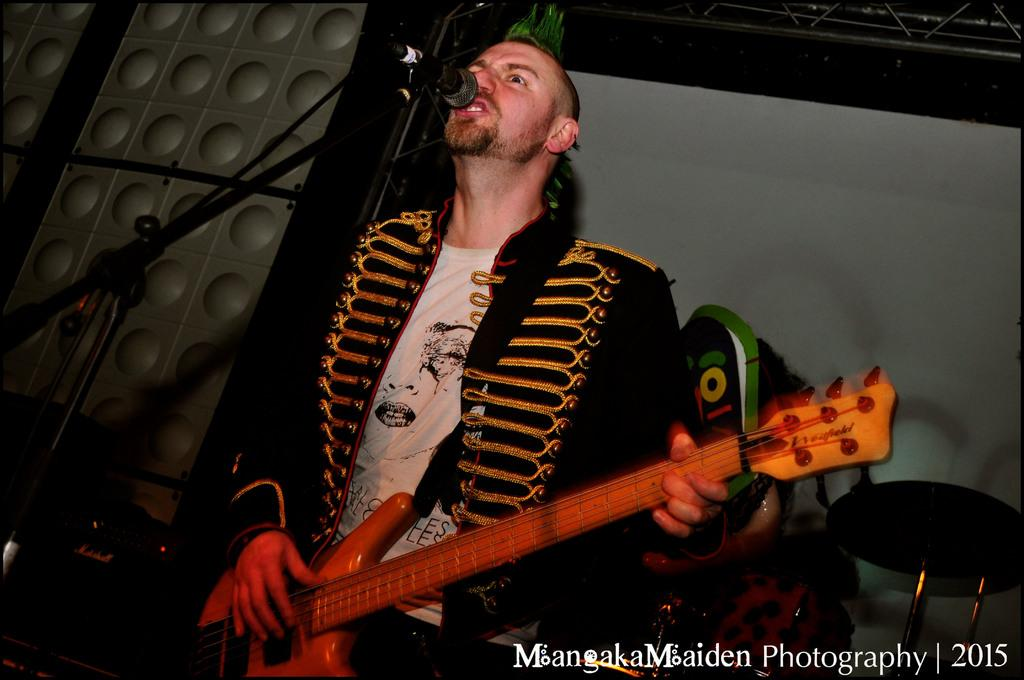What is the man in the image doing? The man is playing a guitar and singing. What object is the man using to amplify his voice? There is a microphone in the image. What type of furniture is present in the image? There is a chair in the image. What is the man wearing in the image? The man is wearing a black suit. What type of club is the man holding in the image? There is no club present in the image. What is the man writing on the guitar in the image? The man is not writing on the guitar in the image; he is playing it. 